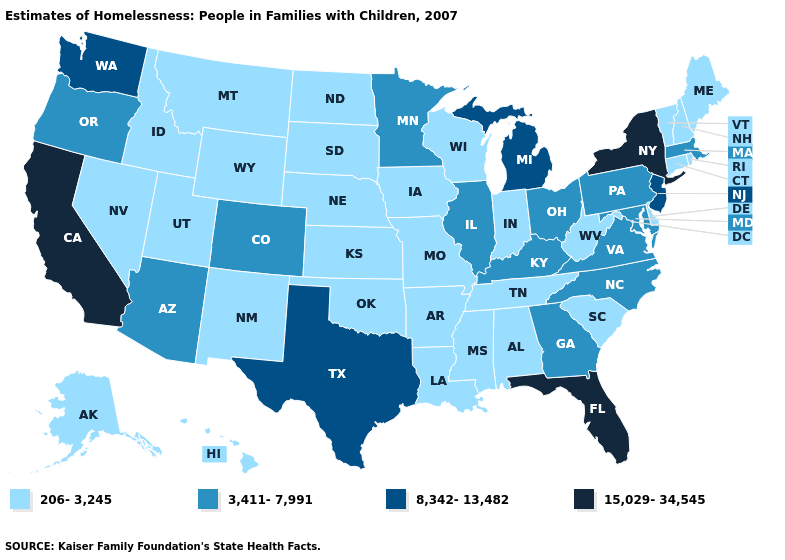Does New York have the highest value in the USA?
Quick response, please. Yes. How many symbols are there in the legend?
Short answer required. 4. Among the states that border Virginia , which have the highest value?
Keep it brief. Kentucky, Maryland, North Carolina. Does Mississippi have the same value as Pennsylvania?
Answer briefly. No. What is the lowest value in the USA?
Short answer required. 206-3,245. What is the lowest value in the USA?
Short answer required. 206-3,245. Name the states that have a value in the range 206-3,245?
Concise answer only. Alabama, Alaska, Arkansas, Connecticut, Delaware, Hawaii, Idaho, Indiana, Iowa, Kansas, Louisiana, Maine, Mississippi, Missouri, Montana, Nebraska, Nevada, New Hampshire, New Mexico, North Dakota, Oklahoma, Rhode Island, South Carolina, South Dakota, Tennessee, Utah, Vermont, West Virginia, Wisconsin, Wyoming. What is the value of New Mexico?
Write a very short answer. 206-3,245. What is the value of Colorado?
Answer briefly. 3,411-7,991. Does Iowa have the highest value in the USA?
Quick response, please. No. Does Arkansas have the highest value in the USA?
Short answer required. No. What is the value of Massachusetts?
Answer briefly. 3,411-7,991. What is the value of Tennessee?
Answer briefly. 206-3,245. Does New York have the highest value in the USA?
Be succinct. Yes. Name the states that have a value in the range 15,029-34,545?
Answer briefly. California, Florida, New York. 